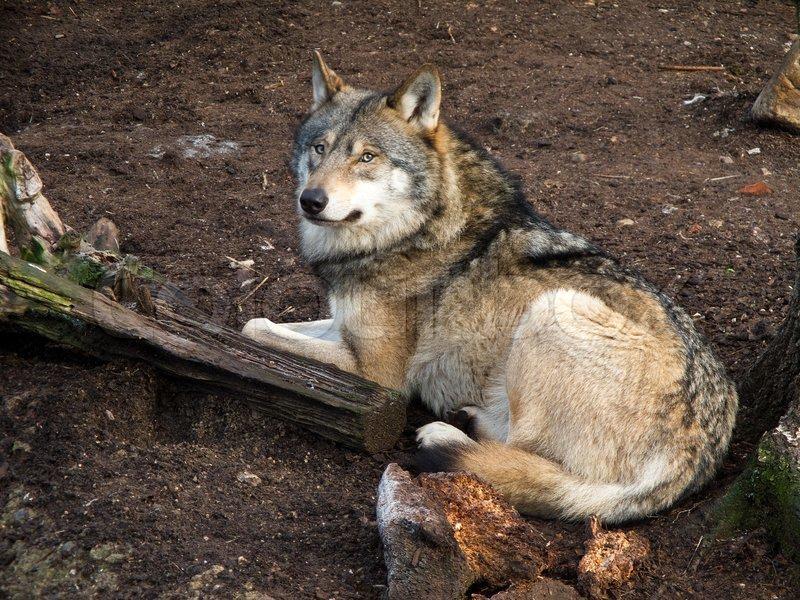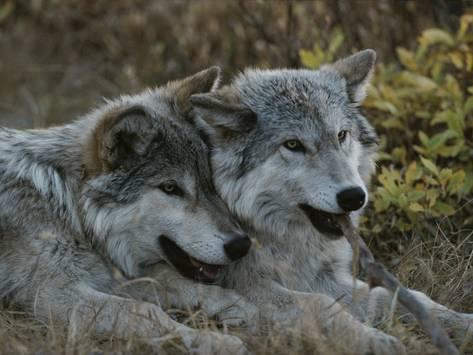The first image is the image on the left, the second image is the image on the right. Examine the images to the left and right. Is the description "In one of the pictures, two wolves are cuddling, and in the other, a wolf is alone and there is a tree or tree bark visible." accurate? Answer yes or no. Yes. The first image is the image on the left, the second image is the image on the right. Given the left and right images, does the statement "There are two wolves snuggling in the right image." hold true? Answer yes or no. Yes. 